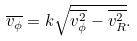Convert formula to latex. <formula><loc_0><loc_0><loc_500><loc_500>\overline { v _ { \phi } } = k \sqrt { \overline { v ^ { 2 } _ { \phi } } - \overline { v ^ { 2 } _ { R } } } .</formula> 